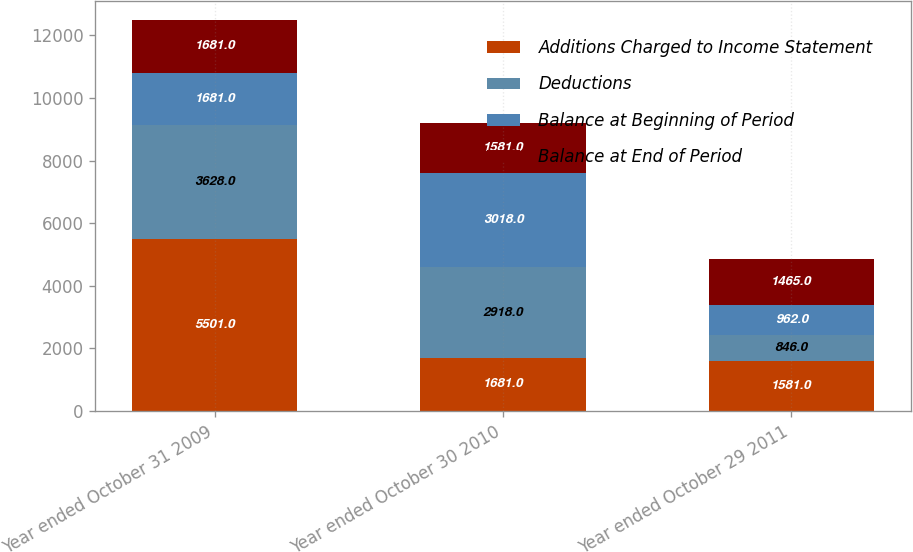Convert chart. <chart><loc_0><loc_0><loc_500><loc_500><stacked_bar_chart><ecel><fcel>Year ended October 31 2009<fcel>Year ended October 30 2010<fcel>Year ended October 29 2011<nl><fcel>Additions Charged to Income Statement<fcel>5501<fcel>1681<fcel>1581<nl><fcel>Deductions<fcel>3628<fcel>2918<fcel>846<nl><fcel>Balance at Beginning of Period<fcel>1681<fcel>3018<fcel>962<nl><fcel>Balance at End of Period<fcel>1681<fcel>1581<fcel>1465<nl></chart> 